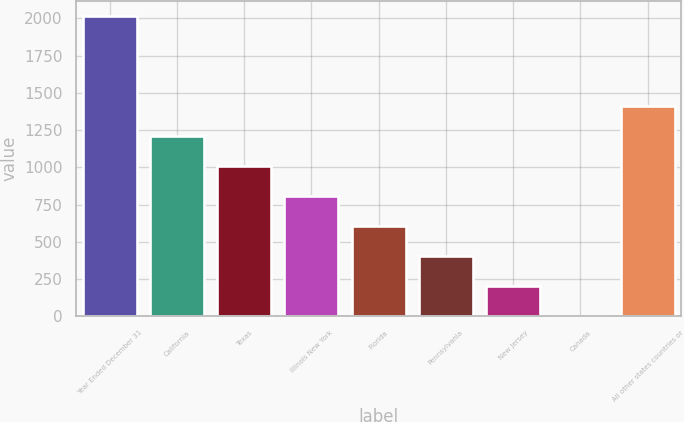Convert chart to OTSL. <chart><loc_0><loc_0><loc_500><loc_500><bar_chart><fcel>Year Ended December 31<fcel>California<fcel>Texas<fcel>Illinois New York<fcel>Florida<fcel>Pennsylvania<fcel>New Jersey<fcel>Canada<fcel>All other states countries or<nl><fcel>2014<fcel>1209.44<fcel>1008.3<fcel>807.16<fcel>606.02<fcel>404.88<fcel>203.74<fcel>2.6<fcel>1410.58<nl></chart> 